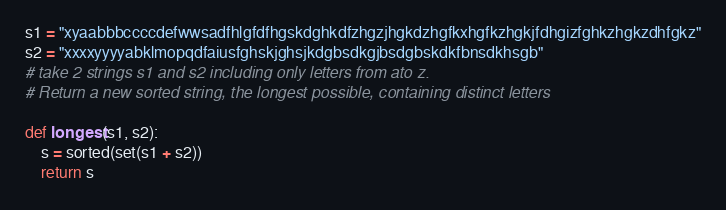<code> <loc_0><loc_0><loc_500><loc_500><_Python_>s1 = "xyaabbbccccdefwwsadfhlgfdfhgskdghkdfzhgzjhgkdzhgfkxhgfkzhgkjfdhgizfghkzhgkzdhfgkz"
s2 = "xxxxyyyyabklmopqdfaiusfghskjghsjkdgbsdkgjbsdgbskdkfbnsdkhsgb"
# take 2 strings s1 and s2 including only letters from ato z. 
# Return a new sorted string, the longest possible, containing distinct letters

def longest(s1, s2):
    s = sorted(set(s1 + s2))
    return s</code> 